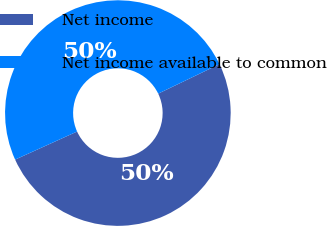<chart> <loc_0><loc_0><loc_500><loc_500><pie_chart><fcel>Net income<fcel>Net income available to common<nl><fcel>50.37%<fcel>49.63%<nl></chart> 